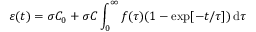<formula> <loc_0><loc_0><loc_500><loc_500>\varepsilon ( t ) = \sigma C _ { 0 } + \sigma C \int _ { 0 } ^ { \infty } f ( \tau ) ( 1 - \exp [ - t / \tau ] ) \, d \tau</formula> 